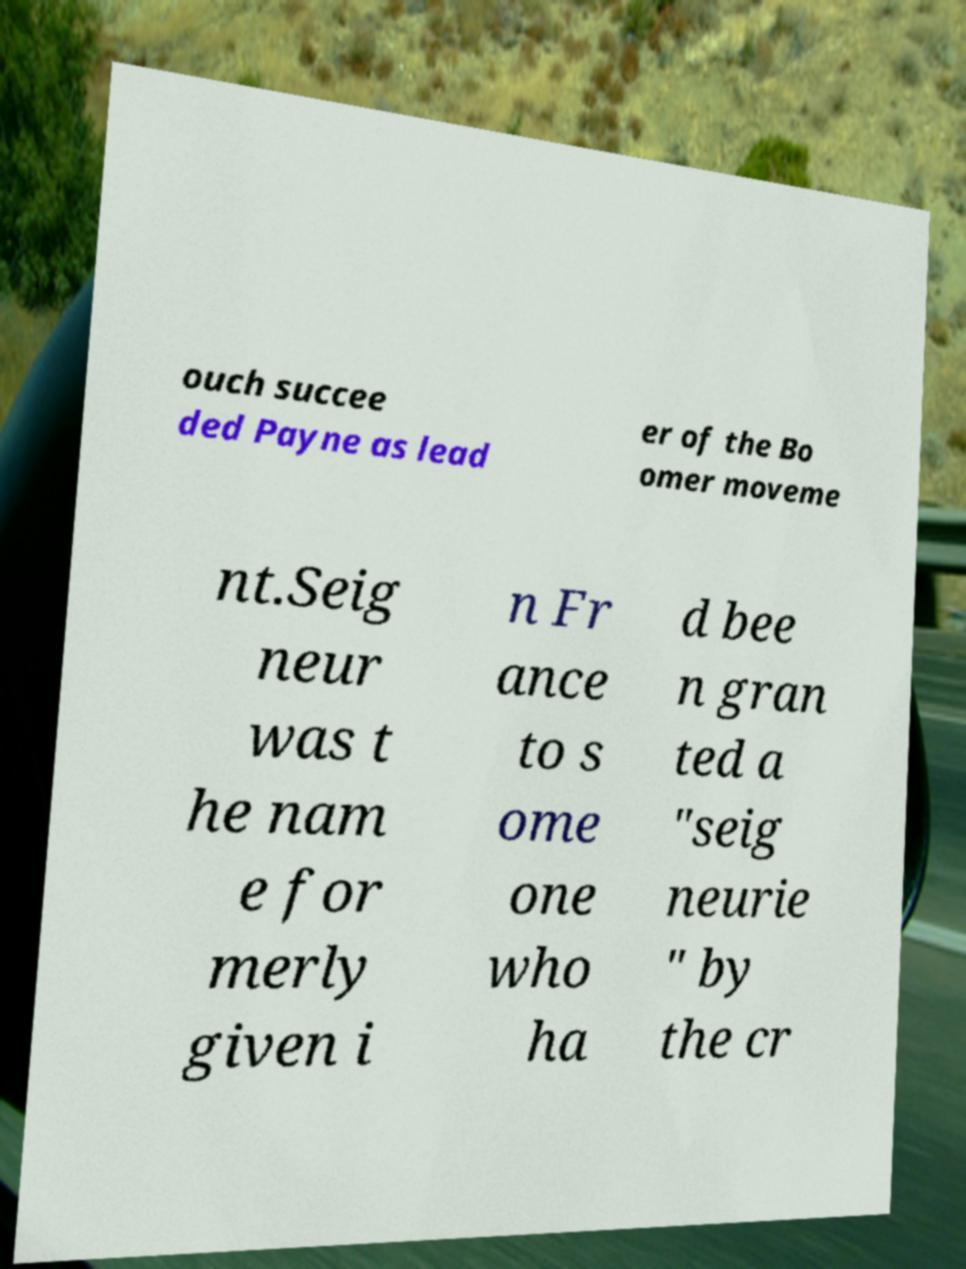Please identify and transcribe the text found in this image. ouch succee ded Payne as lead er of the Bo omer moveme nt.Seig neur was t he nam e for merly given i n Fr ance to s ome one who ha d bee n gran ted a "seig neurie " by the cr 